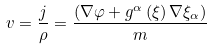Convert formula to latex. <formula><loc_0><loc_0><loc_500><loc_500>v = \frac { j } { \rho } = \frac { \left ( \nabla \varphi + g ^ { \alpha } \left ( \xi \right ) \nabla \xi _ { \alpha } \right ) } { m }</formula> 